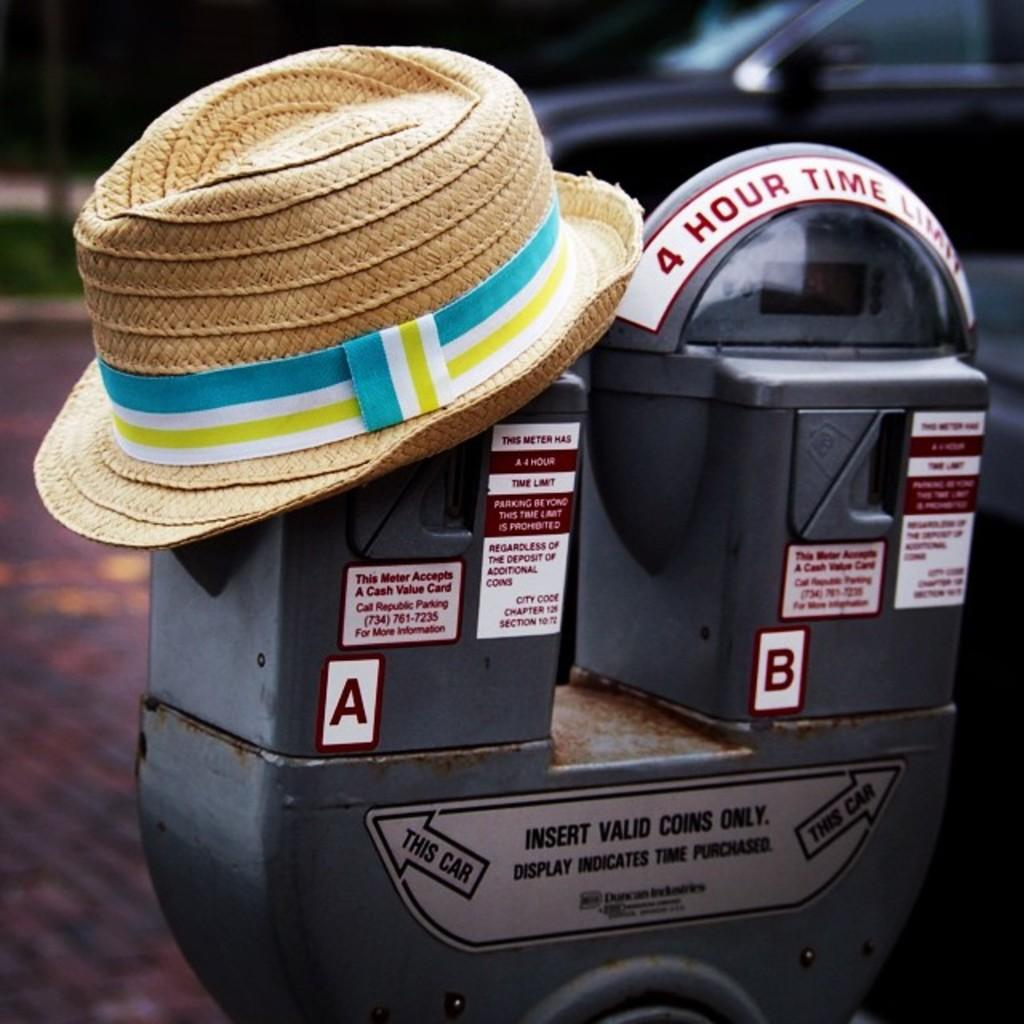<image>
Share a concise interpretation of the image provided. A parking meter with a 4 hour parking time limit 